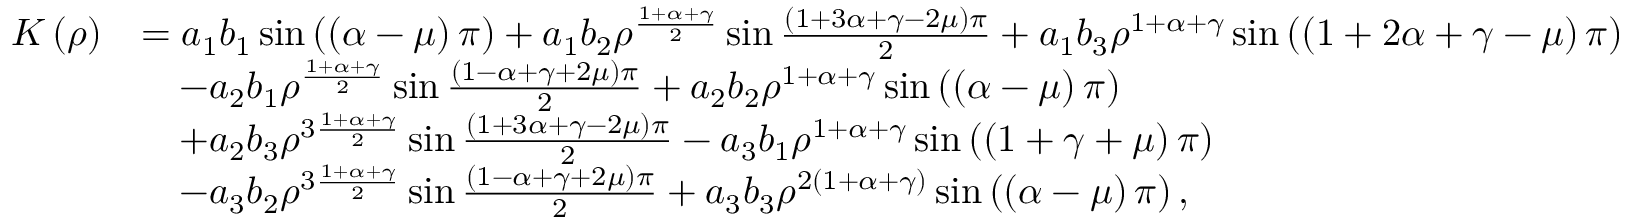<formula> <loc_0><loc_0><loc_500><loc_500>\begin{array} { r l } { K \left ( \rho \right ) } & { = a _ { 1 } b _ { 1 } \sin \left ( \left ( \alpha - \mu \right ) \pi \right ) + a _ { 1 } b _ { 2 } \rho ^ { \frac { 1 + \alpha + \gamma } { 2 } } \sin \frac { \left ( 1 + 3 \alpha + \gamma - 2 \mu \right ) \pi } { 2 } + a _ { 1 } b _ { 3 } \rho ^ { 1 + \alpha + \gamma } \sin \left ( \left ( 1 + 2 \alpha + \gamma - \mu \right ) \pi \right ) } \\ & { \quad - a _ { 2 } b _ { 1 } \rho ^ { \frac { 1 + \alpha + \gamma } { 2 } } \sin \frac { \left ( 1 - \alpha + \gamma + 2 \mu \right ) \pi } { 2 } + a _ { 2 } b _ { 2 } \rho ^ { 1 + \alpha + \gamma } \sin \left ( \left ( \alpha - \mu \right ) \pi \right ) } \\ & { \quad + a _ { 2 } b _ { 3 } \rho ^ { 3 \frac { 1 + \alpha + \gamma } { 2 } } \sin \frac { \left ( 1 + 3 \alpha + \gamma - 2 \mu \right ) \pi } { 2 } - a _ { 3 } b _ { 1 } \rho ^ { 1 + \alpha + \gamma } \sin \left ( \left ( 1 + \gamma + \mu \right ) \pi \right ) } \\ & { \quad - a _ { 3 } b _ { 2 } \rho ^ { 3 \frac { 1 + \alpha + \gamma } { 2 } } \sin \frac { \left ( 1 - \alpha + \gamma + 2 \mu \right ) \pi } { 2 } + a _ { 3 } b _ { 3 } \rho ^ { 2 \left ( 1 + \alpha + \gamma \right ) } \sin \left ( \left ( \alpha - \mu \right ) \pi \right ) , } \end{array}</formula> 